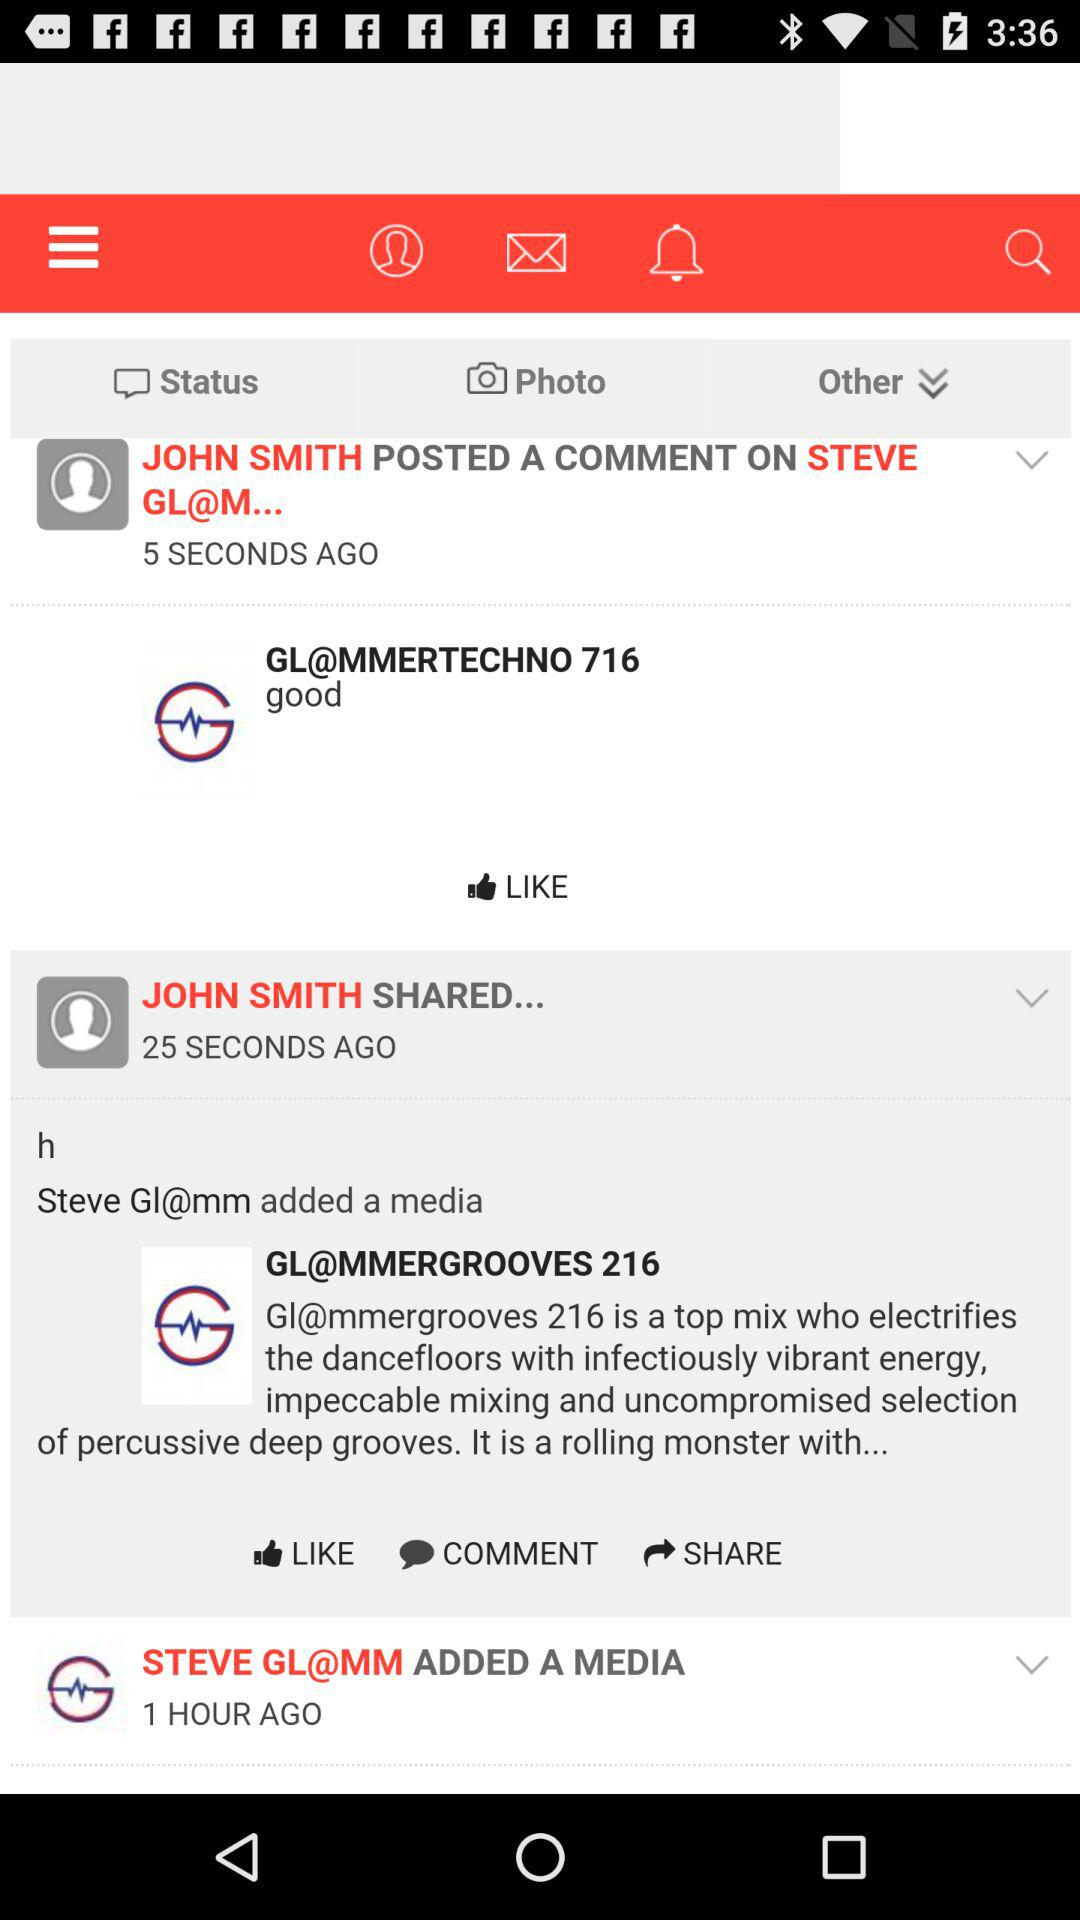How many hours ago did "STEVE Gl@mm" add a media? The media was added 1 hour ago. 